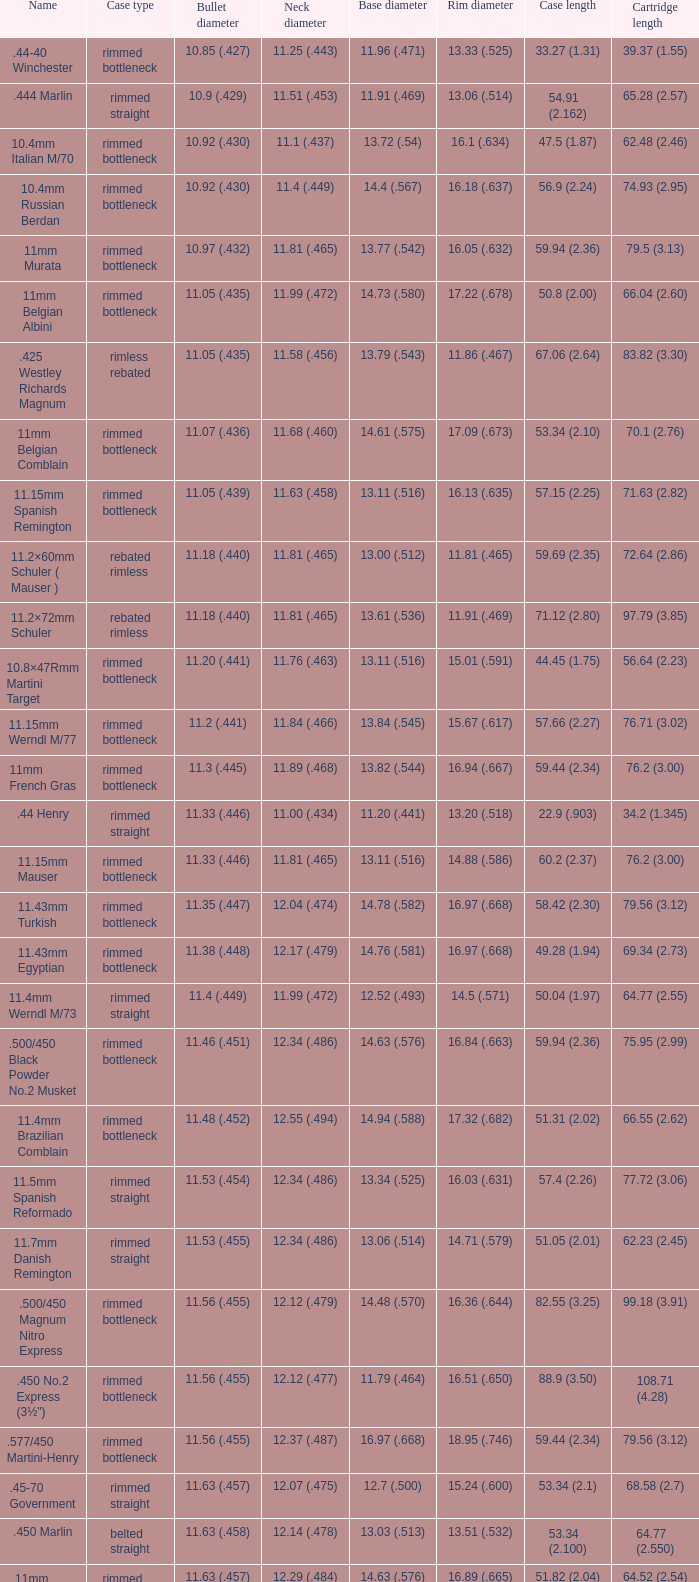5 ( Belted straight. 